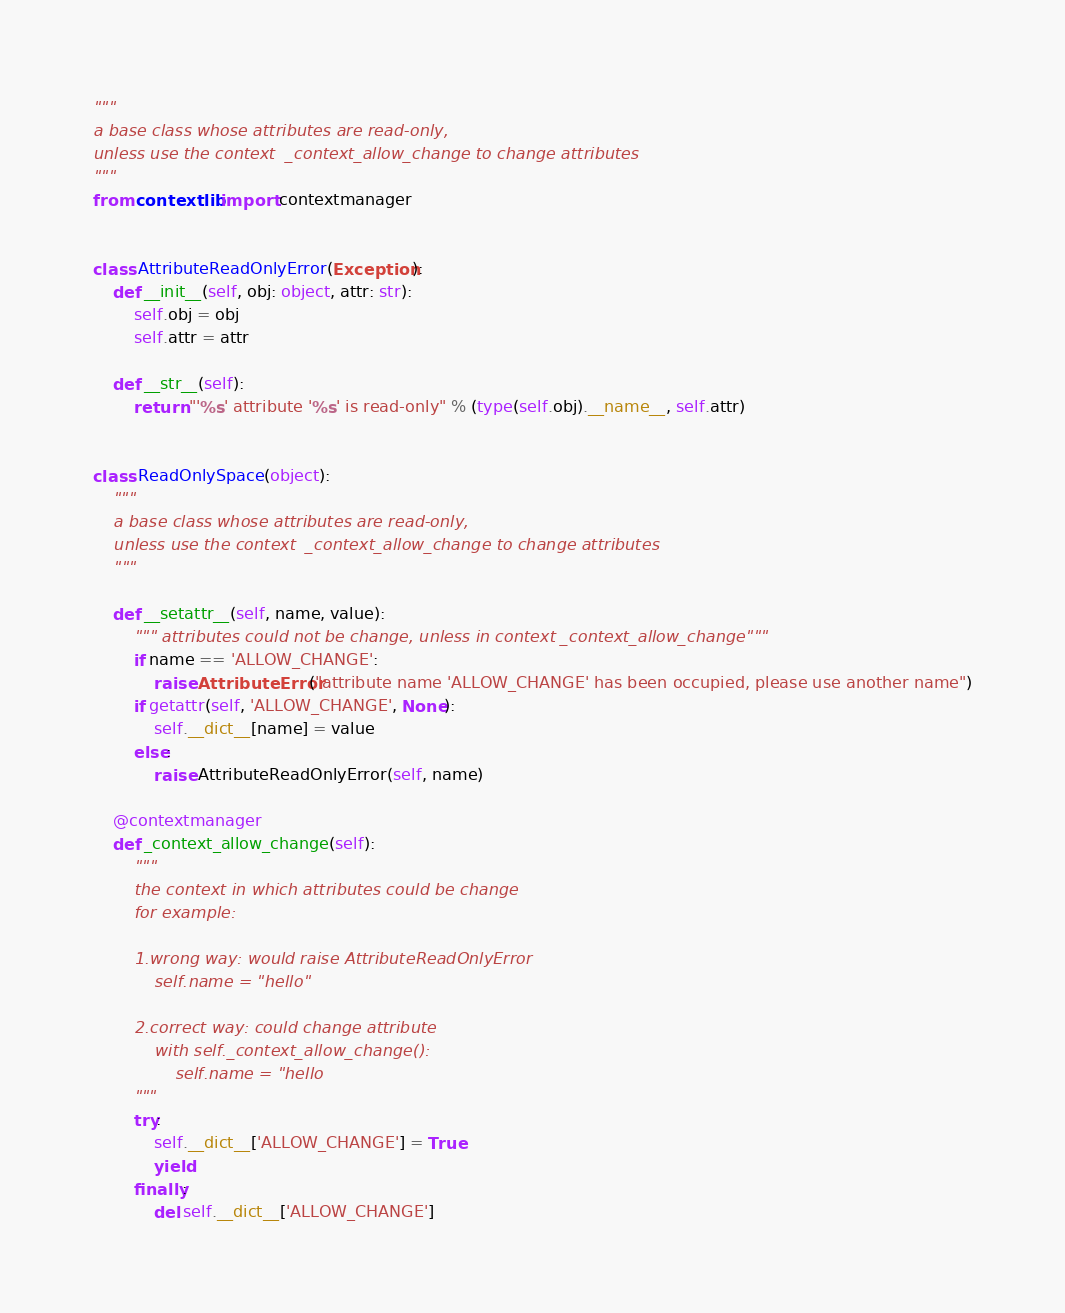<code> <loc_0><loc_0><loc_500><loc_500><_Python_>"""
a base class whose attributes are read-only,
unless use the context  _context_allow_change to change attributes
"""
from contextlib import contextmanager


class AttributeReadOnlyError(Exception):
    def __init__(self, obj: object, attr: str):
        self.obj = obj
        self.attr = attr

    def __str__(self):
        return "'%s' attribute '%s' is read-only" % (type(self.obj).__name__, self.attr)


class ReadOnlySpace(object):
    """
    a base class whose attributes are read-only,
    unless use the context  _context_allow_change to change attributes
    """

    def __setattr__(self, name, value):
        """ attributes could not be change, unless in context _context_allow_change"""
        if name == 'ALLOW_CHANGE':
            raise AttributeError("attribute name 'ALLOW_CHANGE' has been occupied, please use another name")
        if getattr(self, 'ALLOW_CHANGE', None):
            self.__dict__[name] = value
        else:
            raise AttributeReadOnlyError(self, name)

    @contextmanager
    def _context_allow_change(self):
        """
        the context in which attributes could be change
        for example:

        1.wrong way: would raise AttributeReadOnlyError
            self.name = "hello"

        2.correct way: could change attribute
            with self._context_allow_change():
                self.name = "hello
        """
        try:
            self.__dict__['ALLOW_CHANGE'] = True
            yield
        finally:
            del self.__dict__['ALLOW_CHANGE']
</code> 